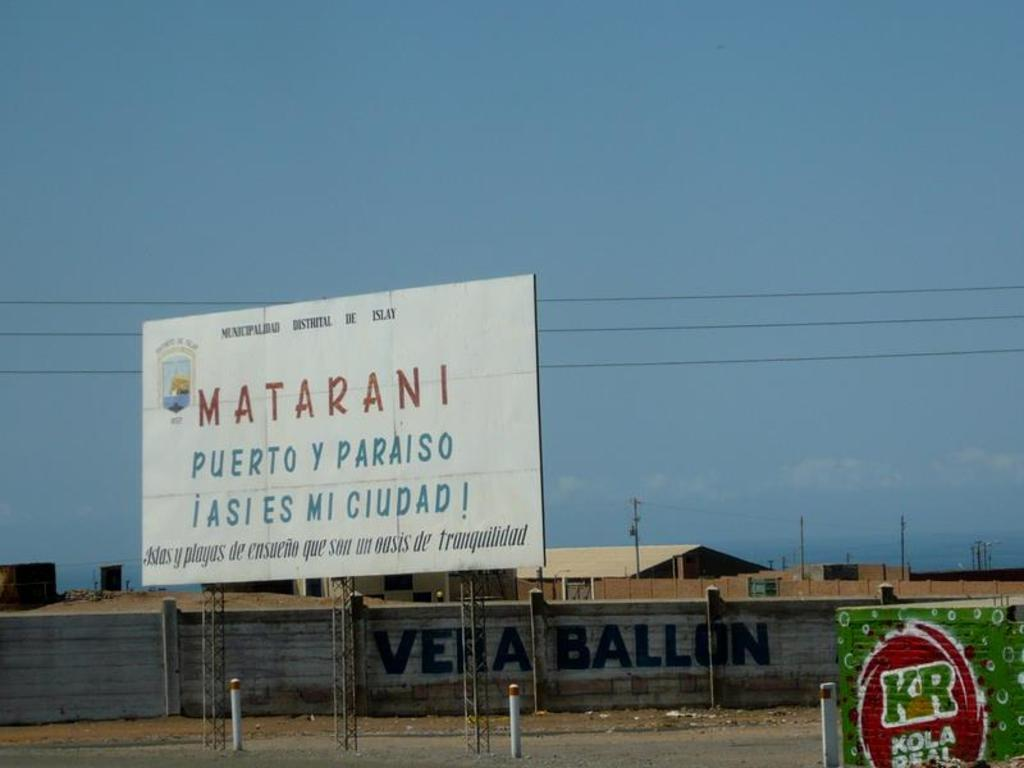Provide a one-sentence caption for the provided image. a billboard for Matarani Puerto y Paraiso on the road side. 